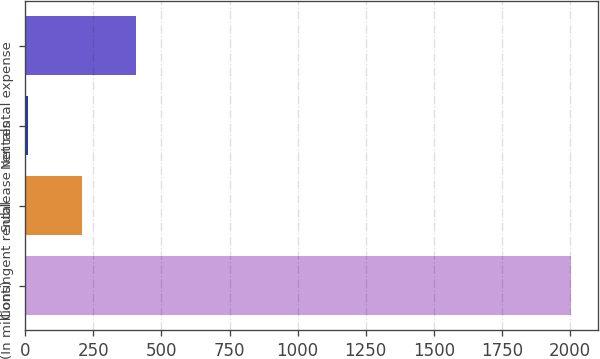Convert chart. <chart><loc_0><loc_0><loc_500><loc_500><bar_chart><fcel>(In millions)<fcel>Contingent rental<fcel>Sublease rentals<fcel>Net rental expense<nl><fcel>2003<fcel>208.4<fcel>9<fcel>407.8<nl></chart> 